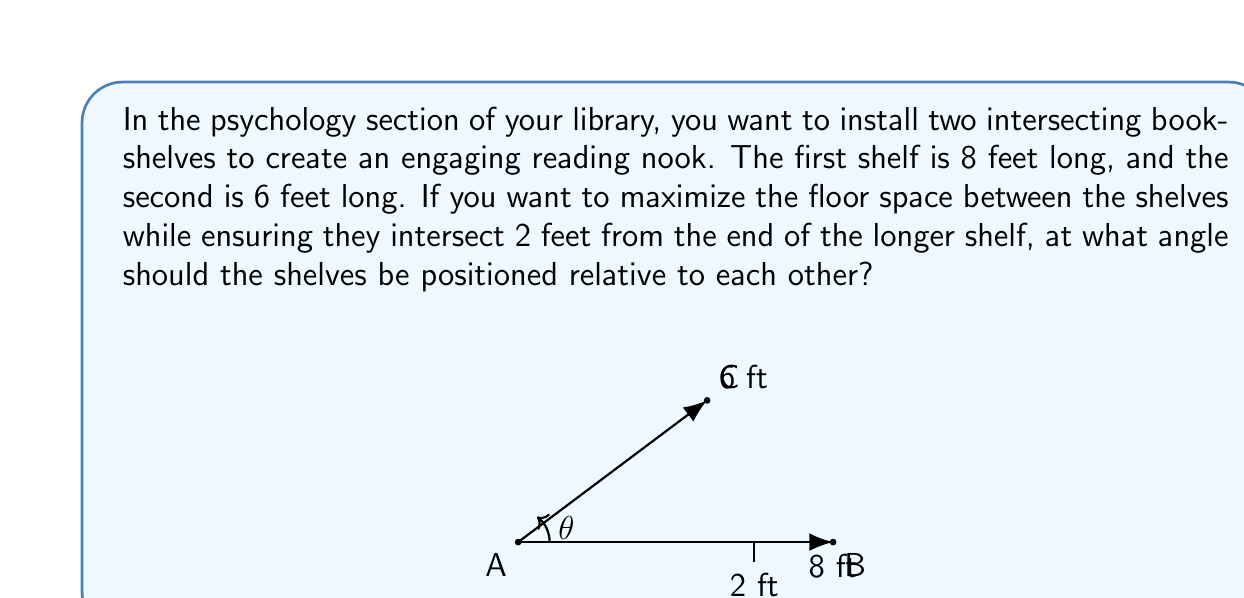What is the answer to this math problem? Let's approach this step-by-step using trigonometry:

1) We can treat this as a triangle problem. The two bookshelves form two sides of a triangle, and we need to find the angle between them.

2) We know the lengths of both sides:
   - Long shelf (AB) = 8 feet
   - Short shelf (AC) = 6 feet

3) We also know that the shelves intersect 2 feet from the end of the longer shelf. This gives us the length of BC:
   BC = 8 - 2 = 6 feet

4) Now we have a triangle where we know all three sides. We can use the law of cosines to find the angle:

   $$a^2 = b^2 + c^2 - 2bc \cos(A)$$

   Where $a$ is the side opposite to the angle we're looking for, and $b$ and $c$ are the other two sides.

5) Plugging in our values:

   $$6^2 = 8^2 + 6^2 - 2(8)(6) \cos(\theta)$$

6) Simplify:

   $$36 = 64 + 36 - 96 \cos(\theta)$$
   $$36 = 100 - 96 \cos(\theta)$$

7) Solve for $\cos(\theta)$:

   $$96 \cos(\theta) = 100 - 36$$
   $$96 \cos(\theta) = 64$$
   $$\cos(\theta) = \frac{64}{96} = \frac{2}{3}$$

8) To get $\theta$, we take the inverse cosine (arccos) of both sides:

   $$\theta = \arccos(\frac{2}{3})$$

9) Calculate:

   $$\theta \approx 53.13°$$

This angle will maximize the floor space between the shelves while meeting the intersection requirement.
Answer: $\theta \approx 53.13°$ 